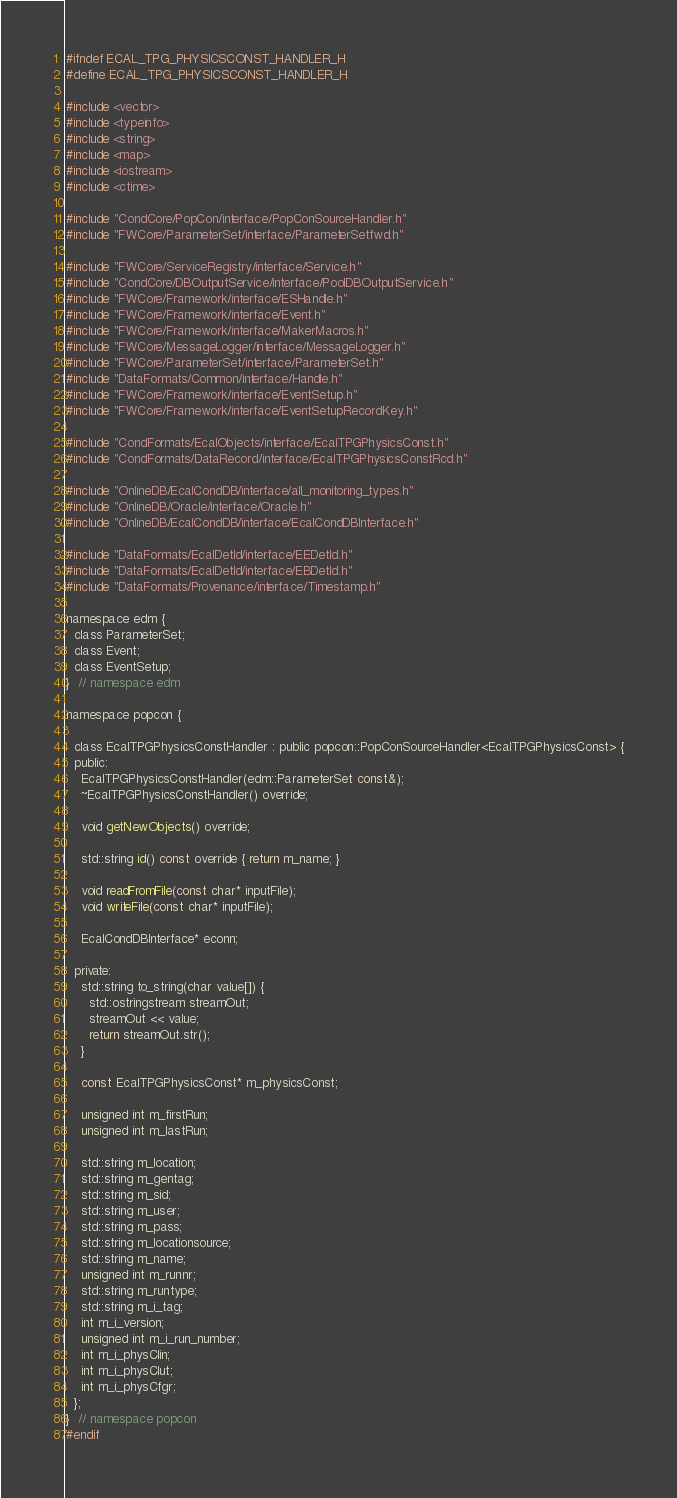Convert code to text. <code><loc_0><loc_0><loc_500><loc_500><_C_>#ifndef ECAL_TPG_PHYSICSCONST_HANDLER_H
#define ECAL_TPG_PHYSICSCONST_HANDLER_H

#include <vector>
#include <typeinfo>
#include <string>
#include <map>
#include <iostream>
#include <ctime>

#include "CondCore/PopCon/interface/PopConSourceHandler.h"
#include "FWCore/ParameterSet/interface/ParameterSetfwd.h"

#include "FWCore/ServiceRegistry/interface/Service.h"
#include "CondCore/DBOutputService/interface/PoolDBOutputService.h"
#include "FWCore/Framework/interface/ESHandle.h"
#include "FWCore/Framework/interface/Event.h"
#include "FWCore/Framework/interface/MakerMacros.h"
#include "FWCore/MessageLogger/interface/MessageLogger.h"
#include "FWCore/ParameterSet/interface/ParameterSet.h"
#include "DataFormats/Common/interface/Handle.h"
#include "FWCore/Framework/interface/EventSetup.h"
#include "FWCore/Framework/interface/EventSetupRecordKey.h"

#include "CondFormats/EcalObjects/interface/EcalTPGPhysicsConst.h"
#include "CondFormats/DataRecord/interface/EcalTPGPhysicsConstRcd.h"

#include "OnlineDB/EcalCondDB/interface/all_monitoring_types.h"
#include "OnlineDB/Oracle/interface/Oracle.h"
#include "OnlineDB/EcalCondDB/interface/EcalCondDBInterface.h"

#include "DataFormats/EcalDetId/interface/EEDetId.h"
#include "DataFormats/EcalDetId/interface/EBDetId.h"
#include "DataFormats/Provenance/interface/Timestamp.h"

namespace edm {
  class ParameterSet;
  class Event;
  class EventSetup;
}  // namespace edm

namespace popcon {

  class EcalTPGPhysicsConstHandler : public popcon::PopConSourceHandler<EcalTPGPhysicsConst> {
  public:
    EcalTPGPhysicsConstHandler(edm::ParameterSet const&);
    ~EcalTPGPhysicsConstHandler() override;

    void getNewObjects() override;

    std::string id() const override { return m_name; }

    void readFromFile(const char* inputFile);
    void writeFile(const char* inputFile);

    EcalCondDBInterface* econn;

  private:
    std::string to_string(char value[]) {
      std::ostringstream streamOut;
      streamOut << value;
      return streamOut.str();
    }

    const EcalTPGPhysicsConst* m_physicsConst;

    unsigned int m_firstRun;
    unsigned int m_lastRun;

    std::string m_location;
    std::string m_gentag;
    std::string m_sid;
    std::string m_user;
    std::string m_pass;
    std::string m_locationsource;
    std::string m_name;
    unsigned int m_runnr;
    std::string m_runtype;
    std::string m_i_tag;
    int m_i_version;
    unsigned int m_i_run_number;
    int m_i_physClin;
    int m_i_physClut;
    int m_i_physCfgr;
  };
}  // namespace popcon
#endif
</code> 